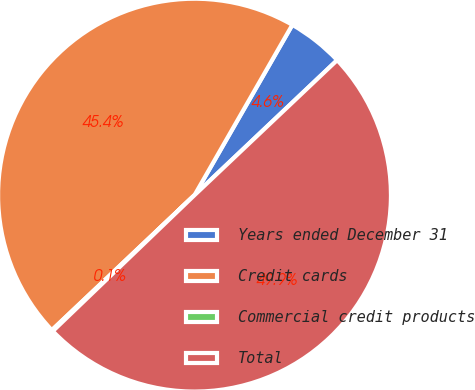<chart> <loc_0><loc_0><loc_500><loc_500><pie_chart><fcel>Years ended December 31<fcel>Credit cards<fcel>Commercial credit products<fcel>Total<nl><fcel>4.64%<fcel>45.36%<fcel>0.11%<fcel>49.89%<nl></chart> 